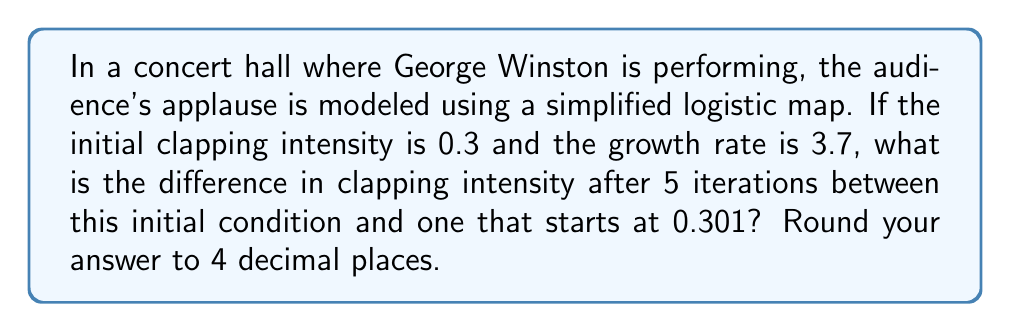Show me your answer to this math problem. To solve this problem, we'll use the logistic map equation and iterate it 5 times for both initial conditions. Then we'll compare the results.

The logistic map is given by:

$$x_{n+1} = rx_n(1-x_n)$$

Where $r$ is the growth rate and $x_n$ is the population (in this case, clapping intensity) at time $n$.

Let's calculate for both initial conditions:

1. Initial condition $x_0 = 0.3$:

   $x_1 = 3.7 \cdot 0.3 \cdot (1-0.3) = 0.777$
   $x_2 = 3.7 \cdot 0.777 \cdot (1-0.777) = 0.6407$
   $x_3 = 3.7 \cdot 0.6407 \cdot (1-0.6407) = 0.8524$
   $x_4 = 3.7 \cdot 0.8524 \cdot (1-0.8524) = 0.4661$
   $x_5 = 3.7 \cdot 0.4661 \cdot (1-0.4661) = 0.9199$

2. Initial condition $x_0 = 0.301$:

   $x_1 = 3.7 \cdot 0.301 \cdot (1-0.301) = 0.7797$
   $x_2 = 3.7 \cdot 0.7797 \cdot (1-0.7797) = 0.6364$
   $x_3 = 3.7 \cdot 0.6364 \cdot (1-0.6364) = 0.8561$
   $x_4 = 3.7 \cdot 0.8561 \cdot (1-0.8561) = 0.4563$
   $x_5 = 3.7 \cdot 0.4563 \cdot (1-0.4563) = 0.9165$

Now, we calculate the difference between these two final values:

$|0.9199 - 0.9165| = 0.0034$

Rounding to 4 decimal places gives us 0.0034.
Answer: 0.0034 